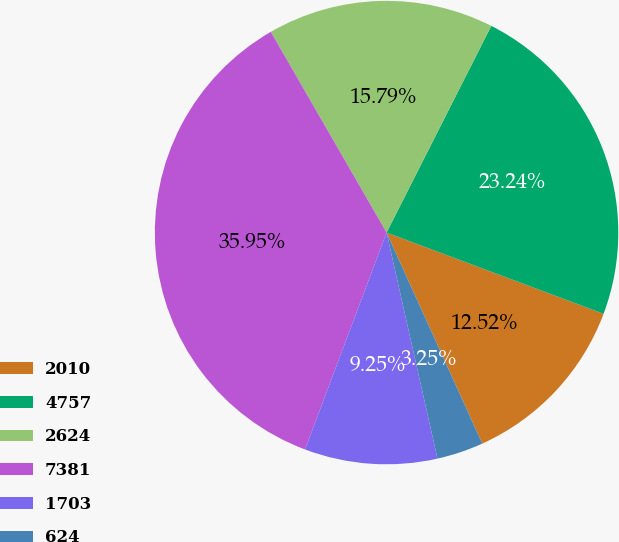<chart> <loc_0><loc_0><loc_500><loc_500><pie_chart><fcel>2010<fcel>4757<fcel>2624<fcel>7381<fcel>1703<fcel>624<nl><fcel>12.52%<fcel>23.24%<fcel>15.79%<fcel>35.95%<fcel>9.25%<fcel>3.25%<nl></chart> 